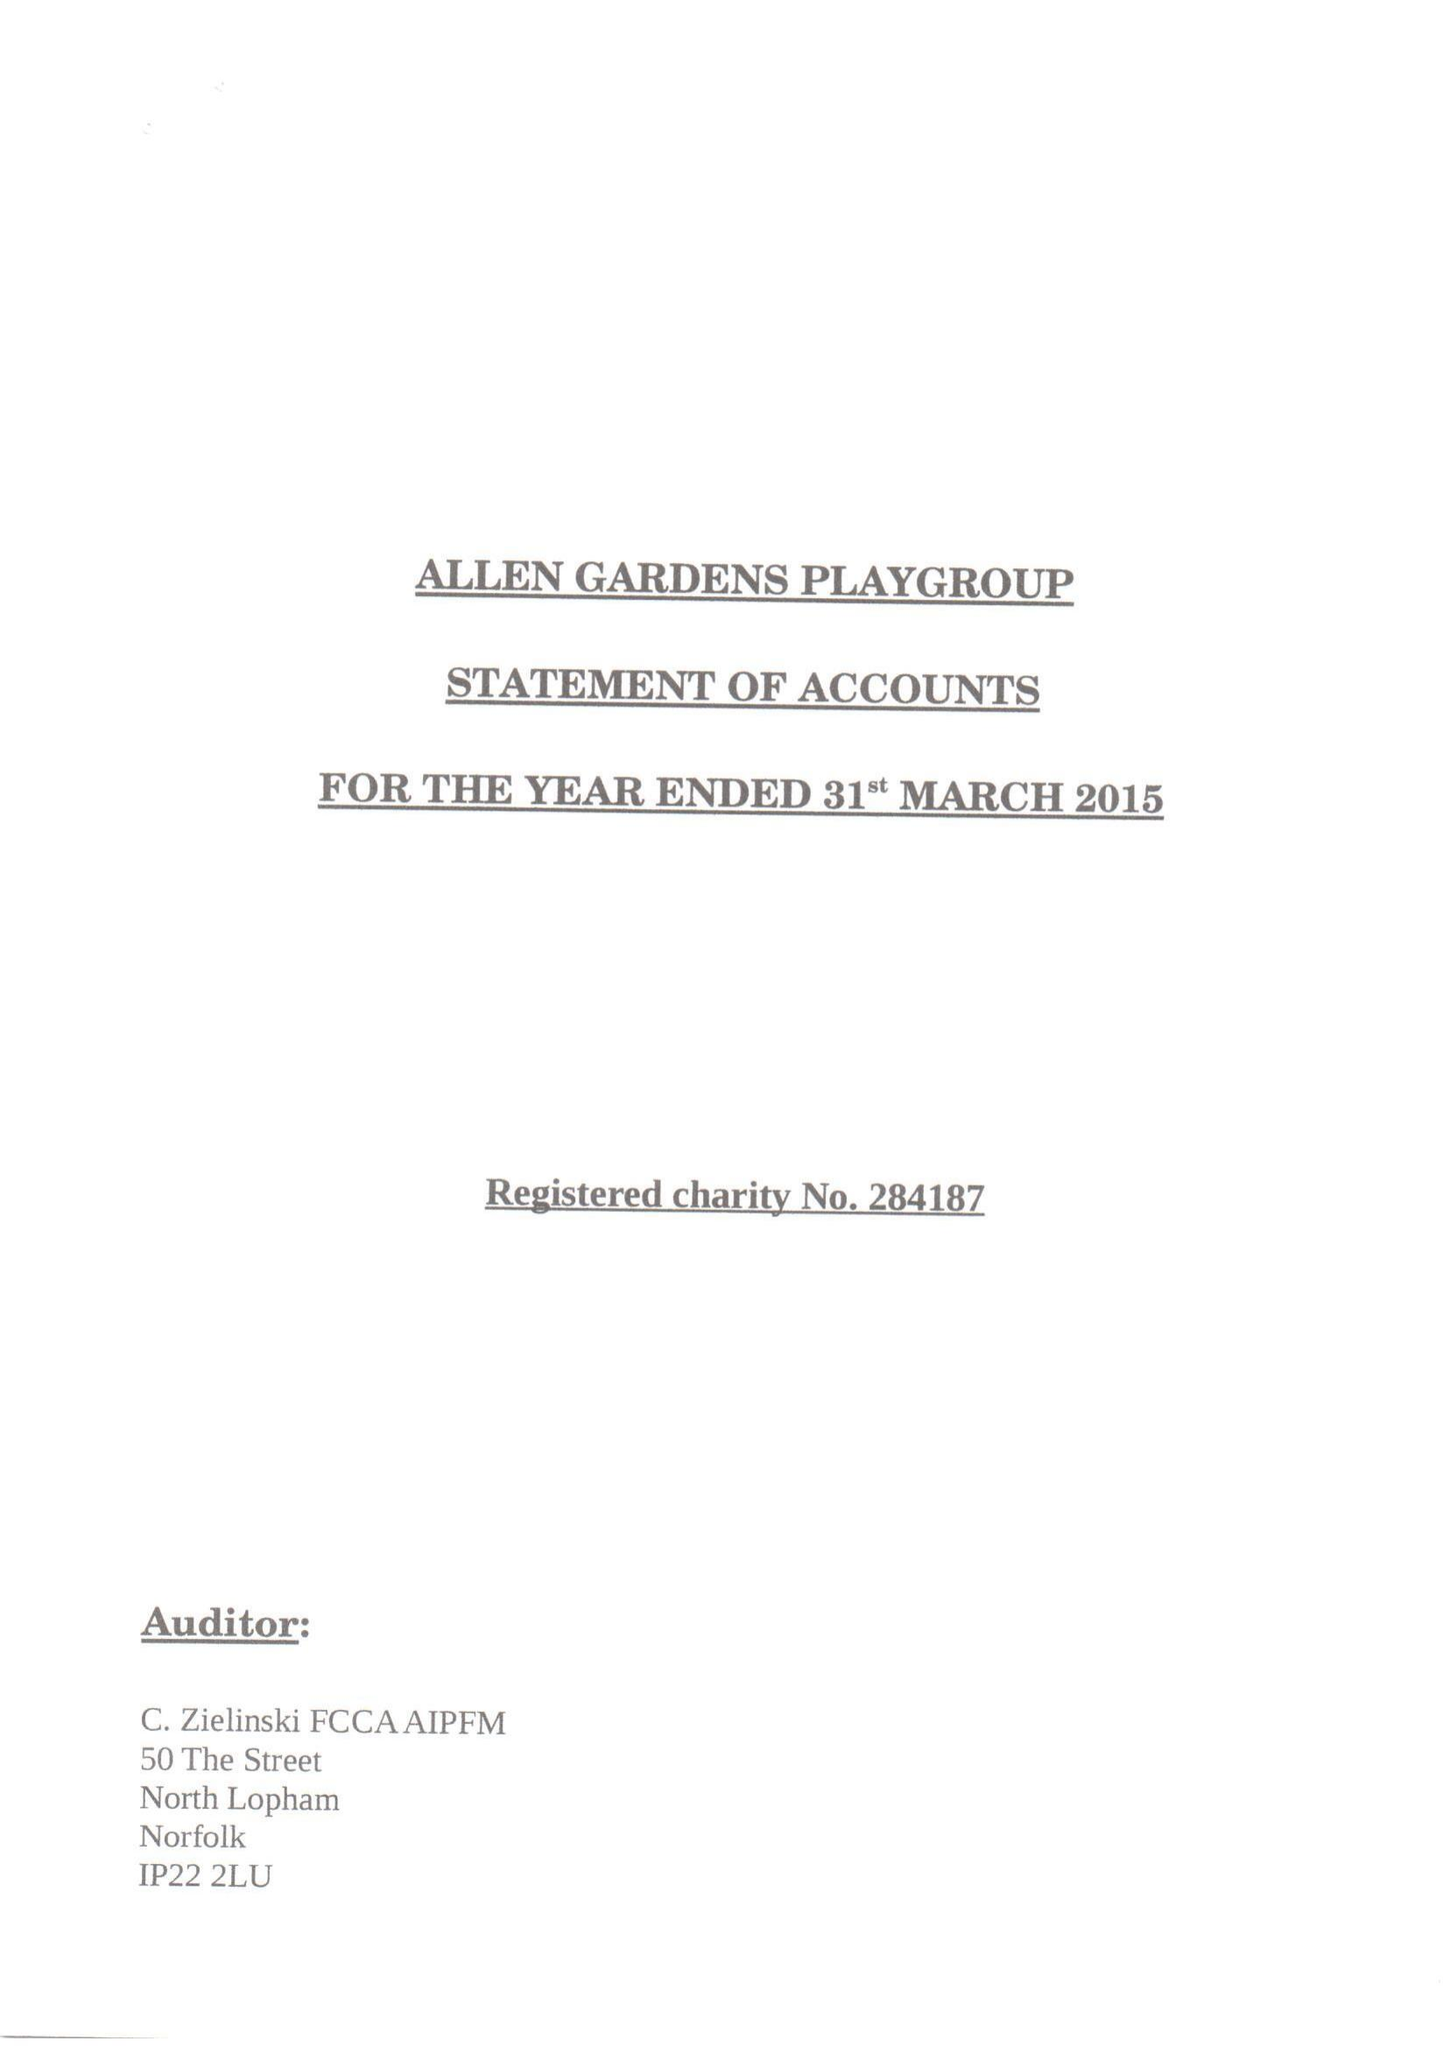What is the value for the address__postcode?
Answer the question using a single word or phrase. E1 5EH 